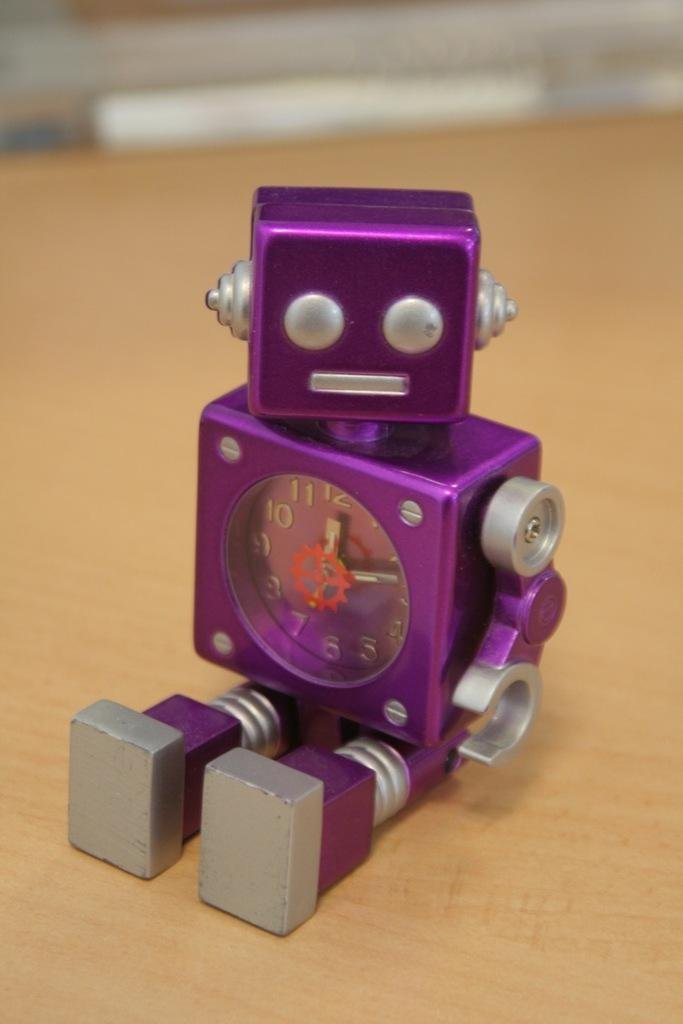What is the main subject of the image? The main subject of the image is a clock in the shape of a small robot. Where is the clock located in the image? The clock is placed on a wooden table. Can you describe the top part of the image? The top part of the image is blurred. What type of digestion issues does the robot-shaped clock have in the image? There are no digestion issues mentioned or depicted in the image, as it features a robot-shaped clock on a wooden table. 